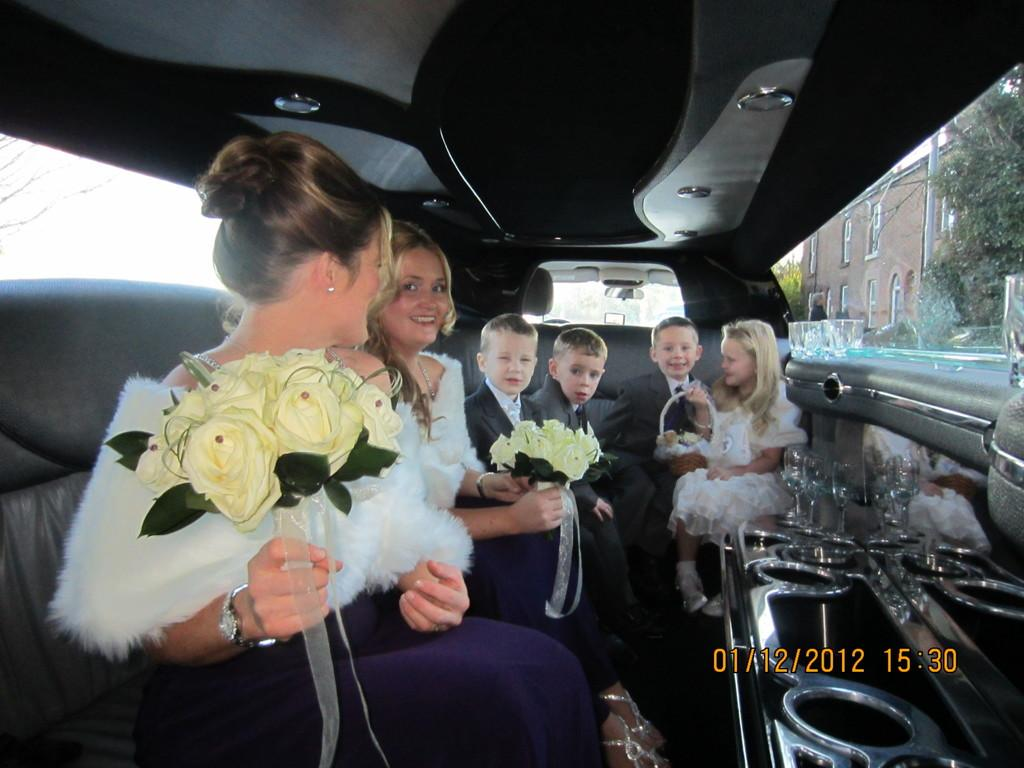How many women are in the image? There are two women in the image. How many kids are in the image? There are four kids in the image. Where are the people in the image sitting? The people are sitting in a car. What objects can be seen on the right side of the image? There are wine glasses on the right side of the image. What structures or landmarks are visible in the image? There is a building and a tree visible in the image. What type of hands are holding the swing in the image? There is no swing present in the image. What type of meal is being prepared in the image? There is no meal preparation visible in the image. 